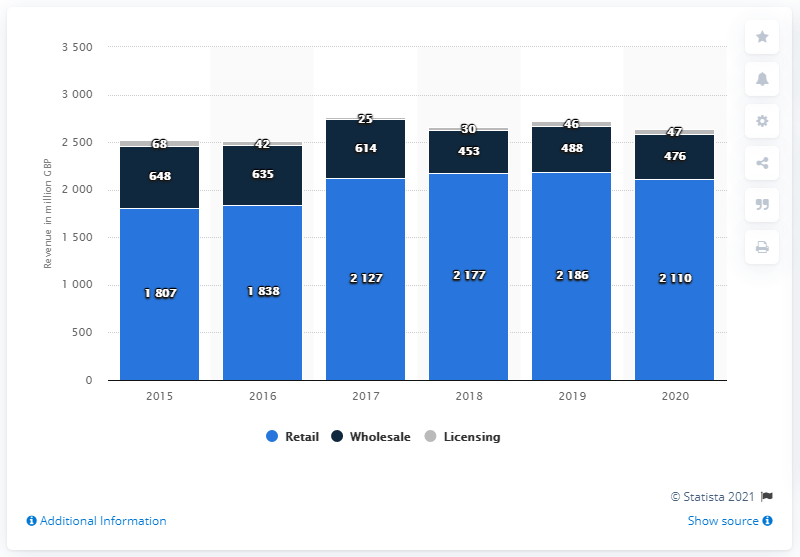Outline some significant characteristics in this image. In 2020, the global revenue of Burberry's retail channel was approximately 2110. 